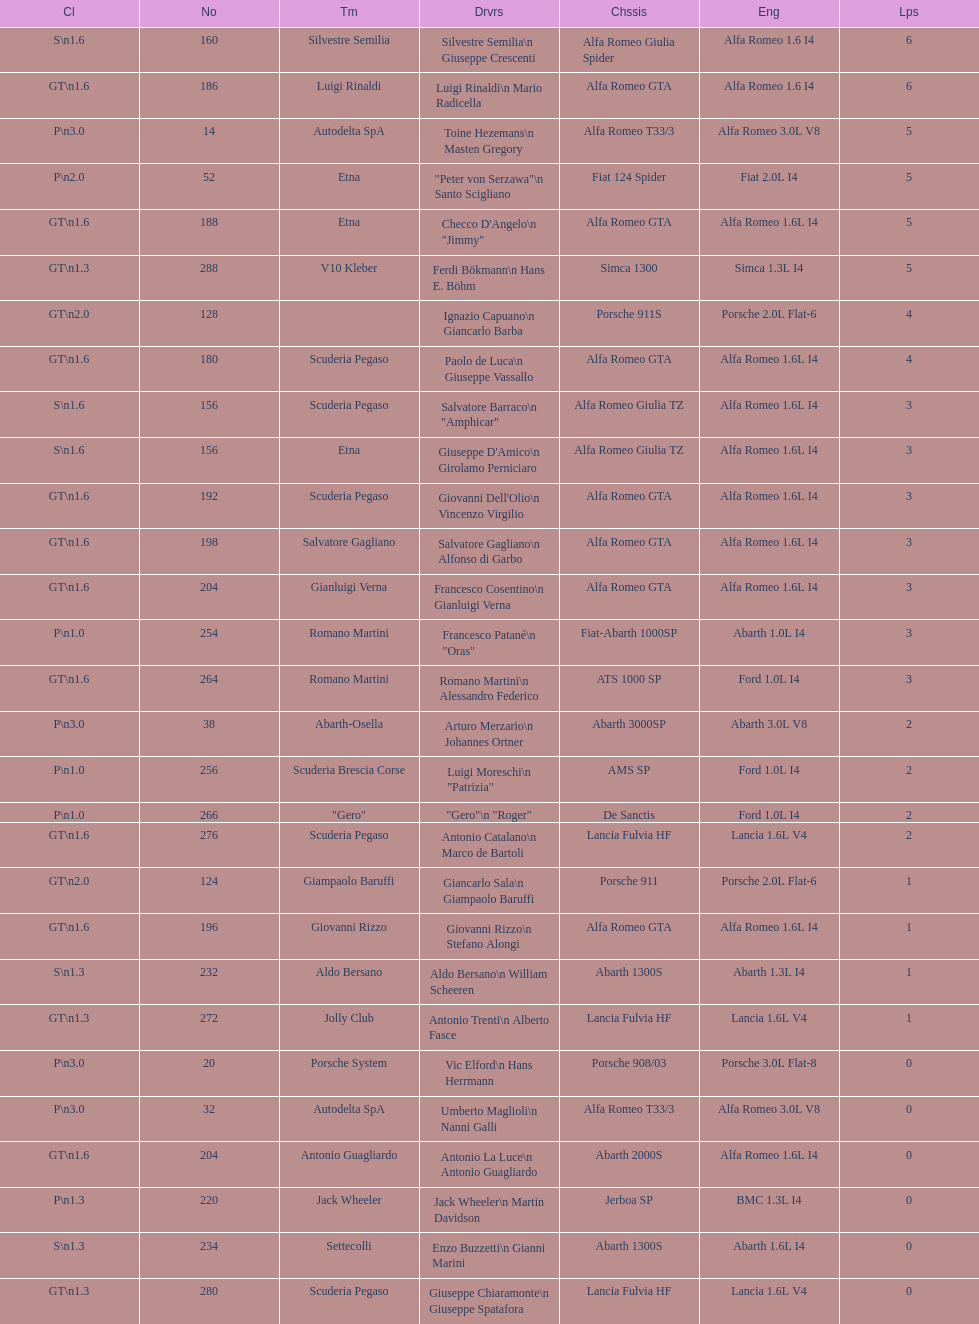How many teams failed to finish the race after 2 laps? 4. 